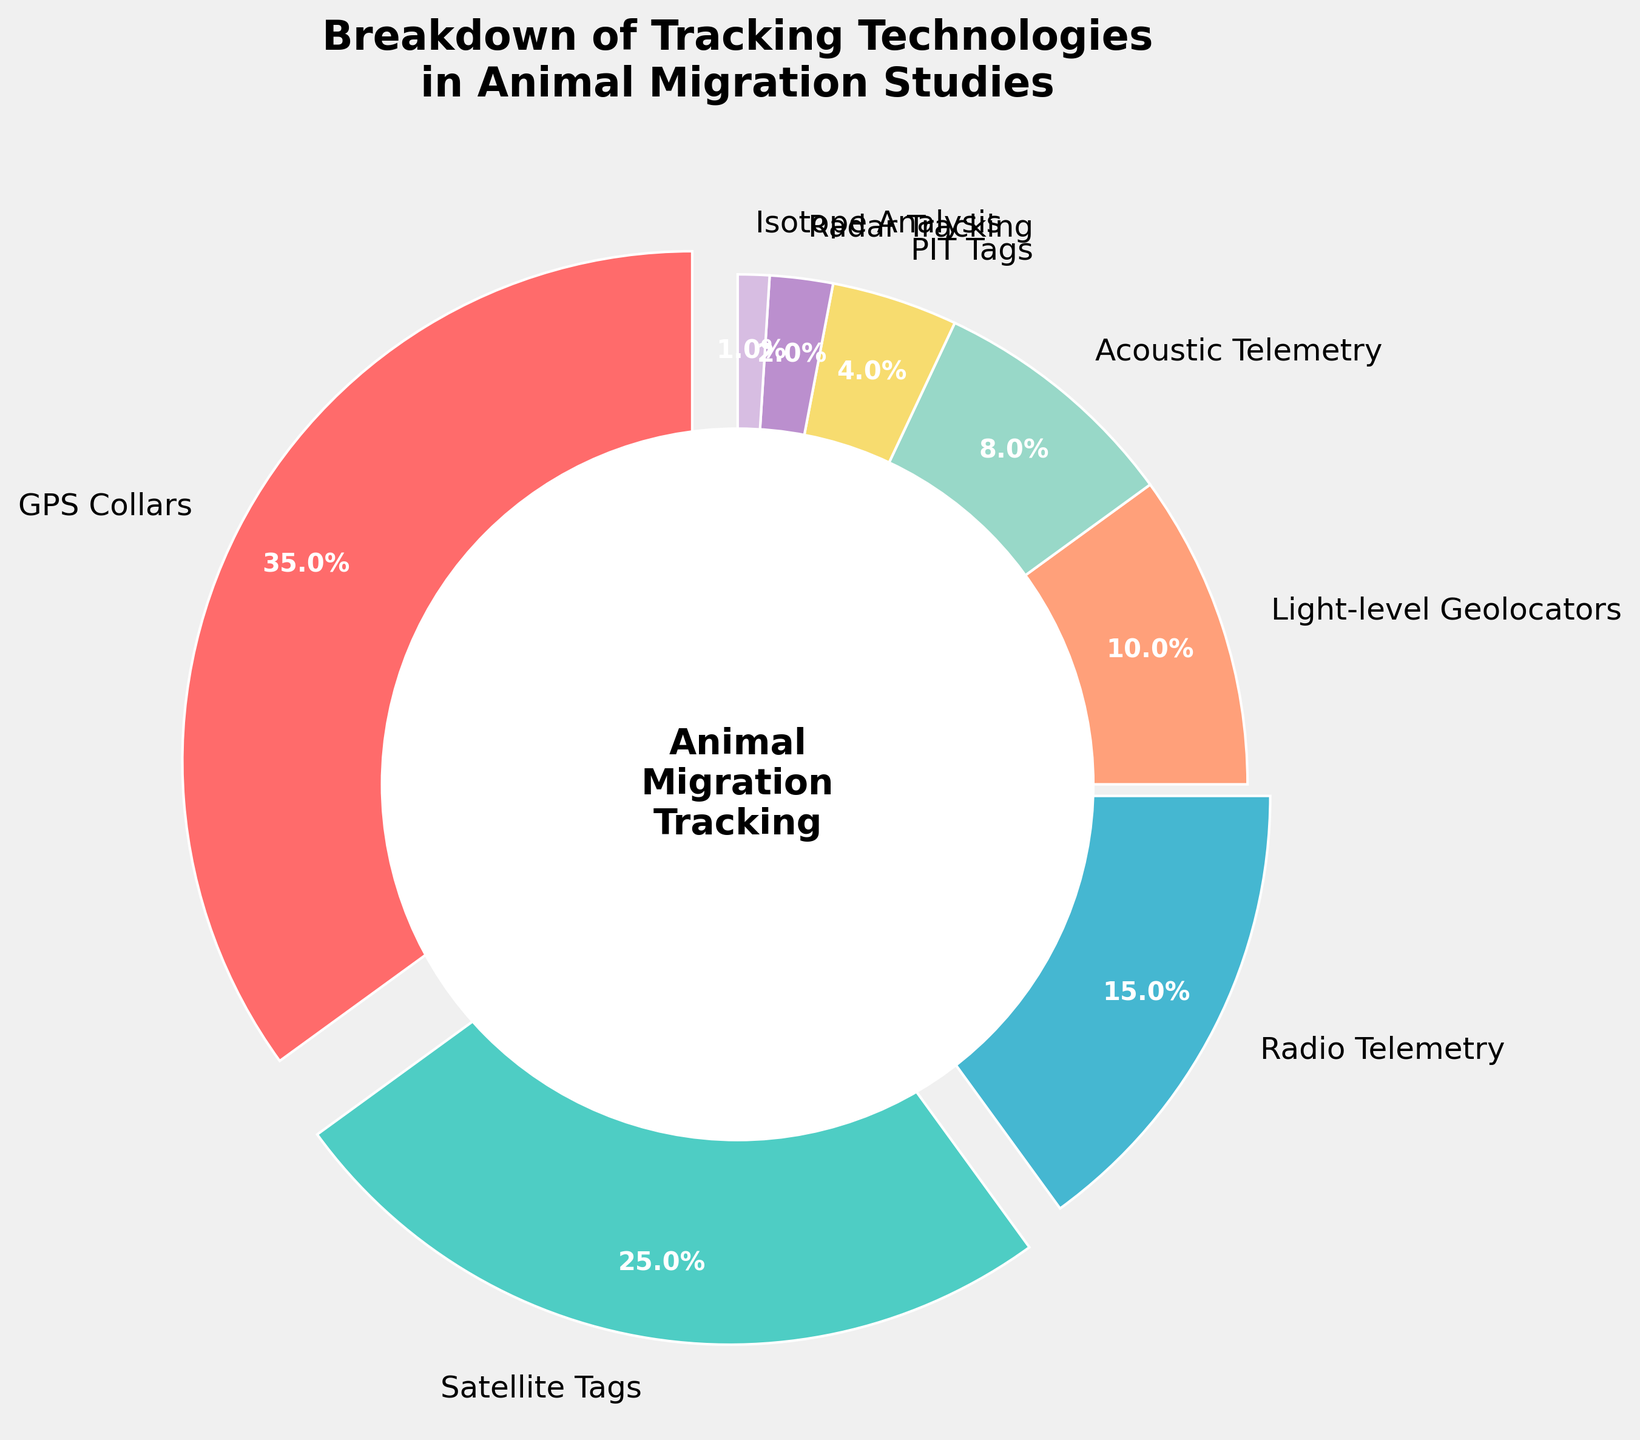What is the most frequently used tracking technology? The largest segment in the pie chart represents the most frequently used technology, which is GPS Collars.
Answer: GPS Collars Which tracking technology is used less frequently than Light-level Geolocators but more frequently than PIT Tags? Light-level Geolocators account for 10% and PIT Tags account for 4%. The tracking technology between these percentages is Acoustic Telemetry, which accounts for 8%.
Answer: Acoustic Telemetry What is the combined percentage of GPS Collars and Satellite Tags? GPS Collars account for 35% and Satellite Tags for 25%. Adding these two percentages together gives 35% + 25% = 60%.
Answer: 60% Between Radio Telemetry and Acoustic Telemetry, which one has a higher usage percentage? Radio Telemetry accounts for 15% while Acoustic Telemetry accounts for 8%, thus Radio Telemetry has a higher usage percentage.
Answer: Radio Telemetry What is the total percentage for all the technologies that are used less than 10%? Adding the percentages of Acoustic Telemetry, PIT Tags, Radar Tracking, and Isotope Analysis: 8% + 4% + 2% + 1% = 15%.
Answer: 15% Which technology is represented by the smallest segment in the pie chart? The smallest segment in the pie chart corresponds to Isotope Analysis, which accounts for 1%.
Answer: Isotope Analysis Is the combined percentage of Radio Telemetry and Light-level Geolocators greater than or equal to 25%? Radio Telemetry accounts for 15% and Light-level Geolocators for 10%. Adding these two values gives 15% + 10% = 25%, which is equal to 25%.
Answer: Yes How does the percentage usage of GPS Collars compare to the total percentage of both Acoustic Telemetry and PIT Tags combined? GPS Collars account for 35%. Acoustic Telemetry and PIT Tags together account for 8% + 4% = 12%. 35% is significantly greater than 12%.
Answer: GPS Collars have a higher percentage What is the difference between the percentages of GPS Collars and Radio Telemetry? GPS Collars account for 35% and Radio Telemetry for 15%. The difference between them is 35% - 15% = 20%.
Answer: 20% What is the average percentage usage of all technologies that account for more than 15% of the total? The technologies above 15% are GPS Collars (35%) and Satellite Tags (25%). The average is (35% + 25%) / 2 = 30%.
Answer: 30% 